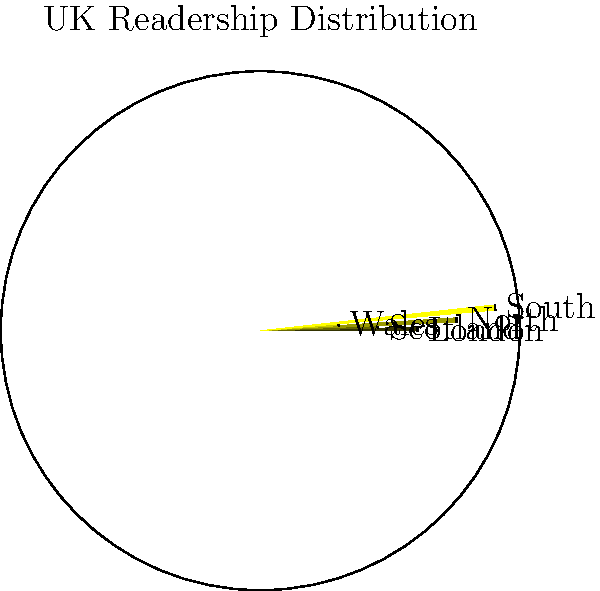As a retired journalist familiar with the British press, examine the polar area chart depicting the distribution of readership across different UK regions. Which region shows the highest percentage of readership, and what strategic implications might this have for a national newspaper's content and marketing approach? To answer this question, let's analyze the polar area chart step-by-step:

1. The chart represents five regions of the UK: London, Scotland, North, Wales, and South.

2. Each sector's area is proportional to the readership percentage in that region.

3. Comparing the sectors:
   - London: moderate size
   - Scotland: smaller size
   - North: second-largest size
   - Wales: smallest size
   - South: largest size

4. The South region clearly has the largest sector, indicating the highest percentage of readership.

5. Strategic implications for a national newspaper:

   a) Content focus: Increase coverage of issues and events relevant to the South of England, while maintaining a balance to avoid alienating other regions.
   
   b) Marketing approach: Allocate more resources to marketing campaigns in the South to capitalize on the existing strong readership.
   
   c) Distribution: Ensure robust distribution networks in the South to meet the higher demand.
   
   d) Regional editions: Consider creating a special Southern edition with expanded local content.
   
   e) Advertising: Attract more advertisers targeting the Southern demographic.
   
   f) Growth strategy: While maintaining the strong Southern readership, develop targeted strategies to increase readership in other regions, particularly in Wales and Scotland where readership appears lower.

6. As an experienced journalist, you would recognize the importance of maintaining a national perspective while acknowledging regional preferences and interests.
Answer: South; focus content and marketing on Southern England while developing strategies to increase readership in other regions. 